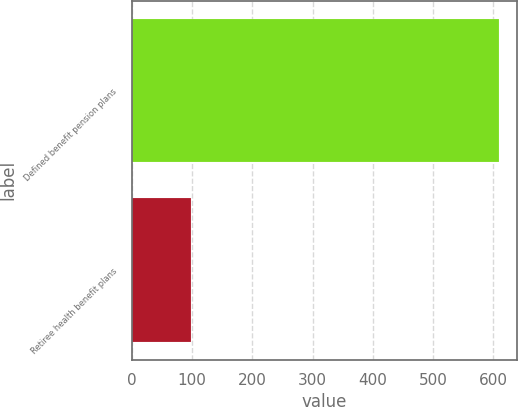Convert chart. <chart><loc_0><loc_0><loc_500><loc_500><bar_chart><fcel>Defined benefit pension plans<fcel>Retiree health benefit plans<nl><fcel>609.9<fcel>98<nl></chart> 